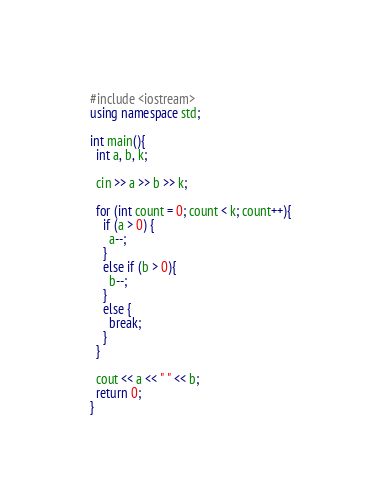<code> <loc_0><loc_0><loc_500><loc_500><_C++_>#include <iostream>
using namespace std;
 
int main(){
  int a, b, k;
  
  cin >> a >> b >> k;
  
  for (int count = 0; count < k; count++){
    if (a > 0) {
      a--;
    }
    else if (b > 0){
      b--;
    }
    else {
      break;
    }
  }
  
  cout << a << " " << b;
  return 0;
}</code> 